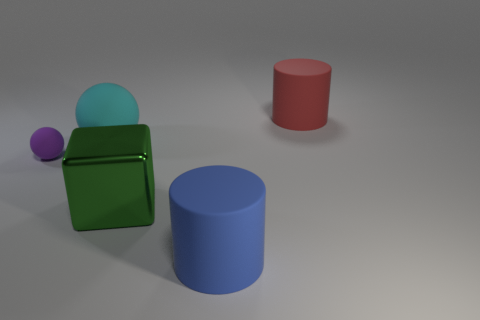Add 1 cubes. How many objects exist? 6 Add 2 big metal cylinders. How many big metal cylinders exist? 2 Subtract 0 blue cubes. How many objects are left? 5 Subtract all cubes. How many objects are left? 4 Subtract 1 blocks. How many blocks are left? 0 Subtract all gray cylinders. Subtract all gray blocks. How many cylinders are left? 2 Subtract all blue cubes. How many purple balls are left? 1 Subtract all purple objects. Subtract all small purple metallic cubes. How many objects are left? 4 Add 4 rubber cylinders. How many rubber cylinders are left? 6 